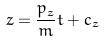Convert formula to latex. <formula><loc_0><loc_0><loc_500><loc_500>z = \frac { p _ { z } } { m } t + c _ { z }</formula> 